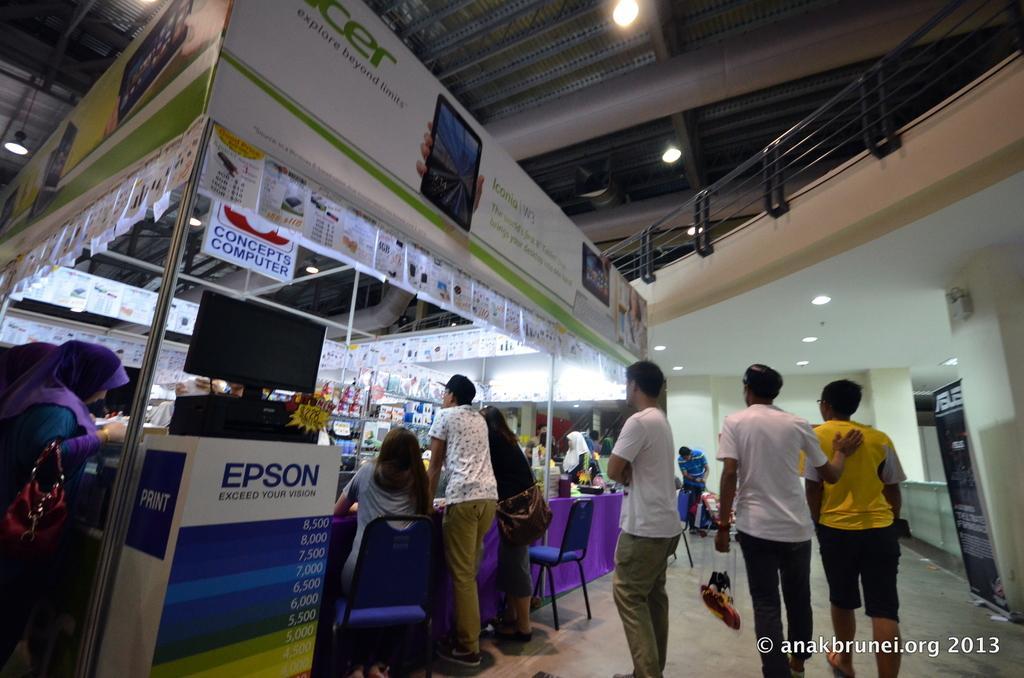Could you give a brief overview of what you see in this image? In this image in the center there are group of persons standing and sitting and walking. On the left side there is a board with some text written on it and on the top of the board there is monitor and on the top there are papers hanging and there are persons. On the right side there is a railing and there are lights hanging. In the background there is a wall and in front of the wall there are persons standing and sitting. 